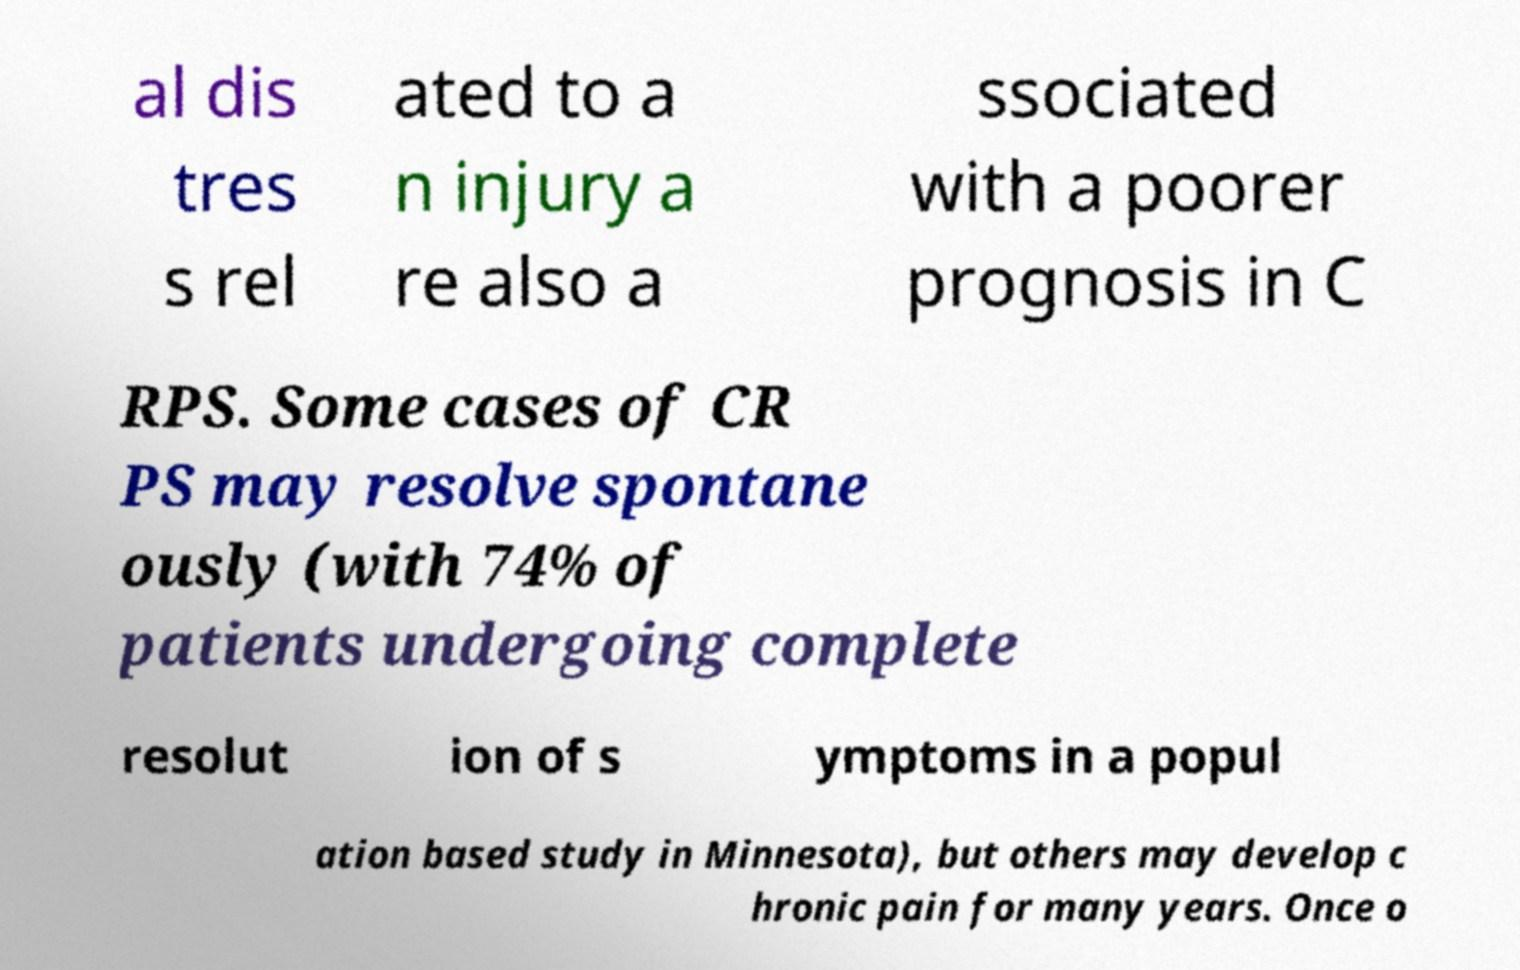There's text embedded in this image that I need extracted. Can you transcribe it verbatim? al dis tres s rel ated to a n injury a re also a ssociated with a poorer prognosis in C RPS. Some cases of CR PS may resolve spontane ously (with 74% of patients undergoing complete resolut ion of s ymptoms in a popul ation based study in Minnesota), but others may develop c hronic pain for many years. Once o 